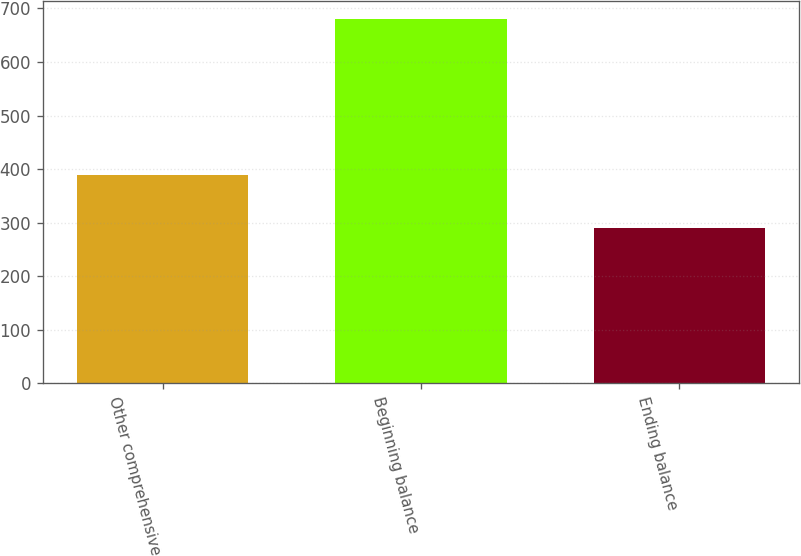<chart> <loc_0><loc_0><loc_500><loc_500><bar_chart><fcel>Other comprehensive<fcel>Beginning balance<fcel>Ending balance<nl><fcel>389.4<fcel>679.9<fcel>290.5<nl></chart> 